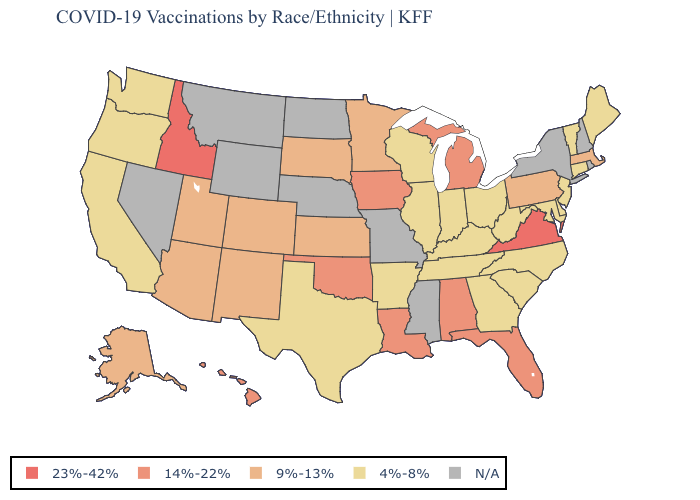Which states have the lowest value in the South?
Quick response, please. Arkansas, Delaware, Georgia, Kentucky, Maryland, North Carolina, South Carolina, Tennessee, Texas, West Virginia. Name the states that have a value in the range N/A?
Keep it brief. Mississippi, Missouri, Montana, Nebraska, Nevada, New Hampshire, New York, North Dakota, Rhode Island, Wyoming. Is the legend a continuous bar?
Write a very short answer. No. Does the first symbol in the legend represent the smallest category?
Concise answer only. No. What is the lowest value in the South?
Short answer required. 4%-8%. What is the value of Arkansas?
Keep it brief. 4%-8%. Is the legend a continuous bar?
Be succinct. No. Name the states that have a value in the range N/A?
Keep it brief. Mississippi, Missouri, Montana, Nebraska, Nevada, New Hampshire, New York, North Dakota, Rhode Island, Wyoming. What is the value of Wisconsin?
Write a very short answer. 4%-8%. Does the map have missing data?
Answer briefly. Yes. Among the states that border Idaho , does Oregon have the lowest value?
Quick response, please. Yes. What is the value of New Jersey?
Short answer required. 4%-8%. Name the states that have a value in the range 9%-13%?
Short answer required. Alaska, Arizona, Colorado, Kansas, Massachusetts, Minnesota, New Mexico, Pennsylvania, South Dakota, Utah. Name the states that have a value in the range N/A?
Keep it brief. Mississippi, Missouri, Montana, Nebraska, Nevada, New Hampshire, New York, North Dakota, Rhode Island, Wyoming. 